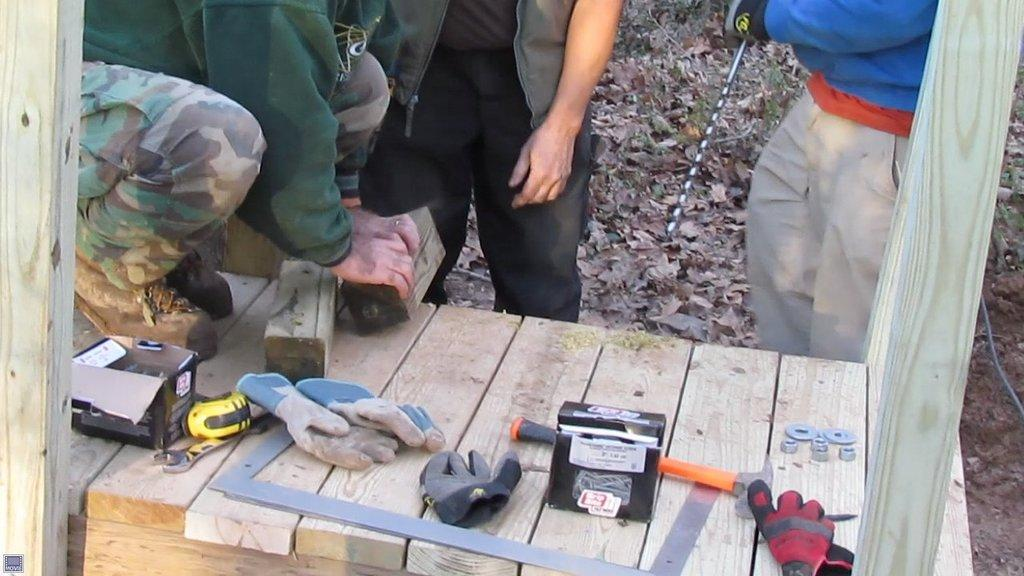How many people are in the image? There are two people standing on the ground in the image. What objects can be seen on the table? Gloves and a box are present on the table in the image. Can you describe the person visible on the table? There is a person visible on the table, possibly a mannequin or a statue. What can be seen in the background of the image? Dried leaves are present in the background of the image. How many babies are crawling on the table in the image? There are no babies present in the image, and no one is crawling on the table. 